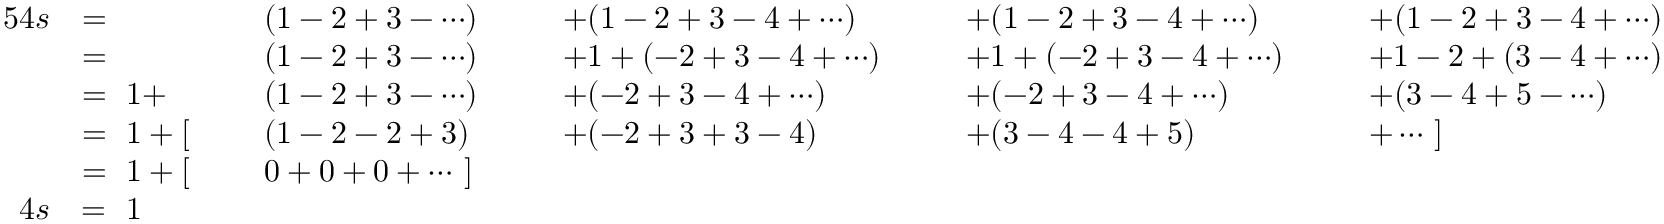Convert formula to latex. <formula><loc_0><loc_0><loc_500><loc_500>{ \begin{array} { r l r l r l r l r l } { { 5 } 4 s } & { = } & & { ( 1 - 2 + 3 - \cdots ) \ \ } & & { + ( 1 - 2 + 3 - 4 + \cdots ) } & & { + ( 1 - 2 + 3 - 4 + \cdots ) } & & { + ( 1 - 2 + 3 - 4 + \cdots ) } \\ & { = } & & { ( 1 - 2 + 3 - \cdots ) } & & { + 1 + ( - 2 + 3 - 4 + \cdots ) \ \ } & & { + 1 + ( - 2 + 3 - 4 + \cdots ) \ \ } & & { + 1 - 2 + ( 3 - 4 + \cdots ) } \\ & { = \ 1 + } & & { ( 1 - 2 + 3 - \cdots ) } & & { + ( - 2 + 3 - 4 + \cdots ) } & & { + ( - 2 + 3 - 4 + \cdots ) } & & { + ( 3 - 4 + 5 - \cdots ) } \\ & { = \ 1 + [ \ } & & { ( 1 - 2 - 2 + 3 ) } & & { + ( - 2 + 3 + 3 - 4 ) } & & { + ( 3 - 4 - 4 + 5 ) } & & { + \cdots \ ] } \\ & { = \ 1 + [ \ } & & { 0 + 0 + 0 + \cdots \ ] } \\ { 4 s } & { = \ 1 } \end{array} }</formula> 